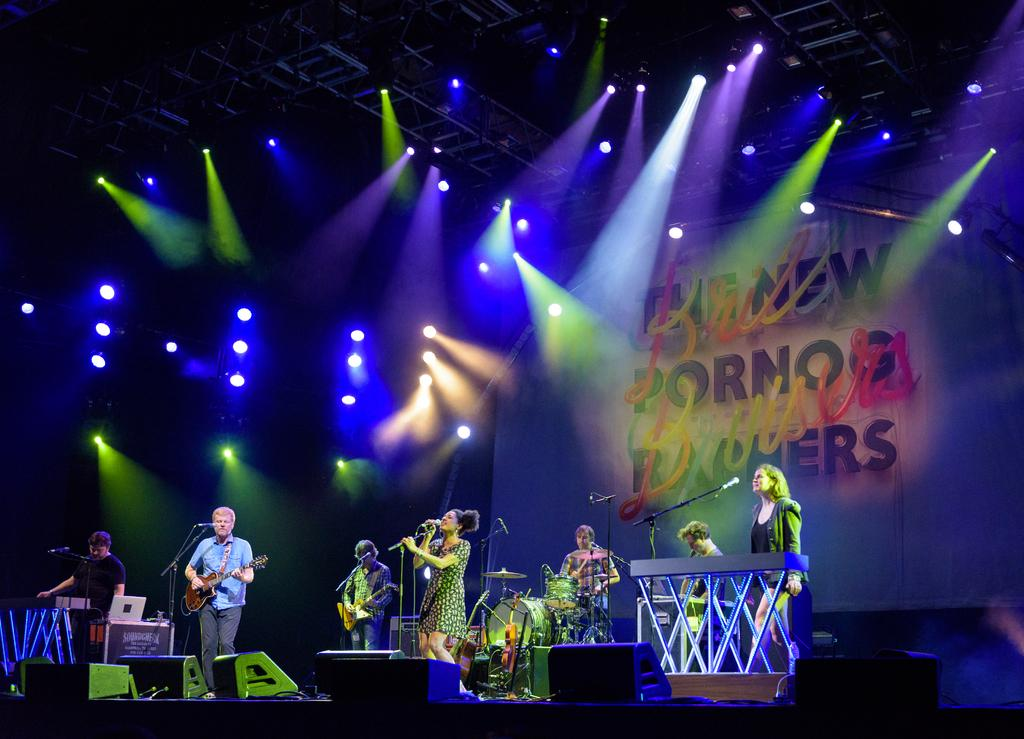What are the people in the image doing? The people in the image are playing music instruments and singing on microphones. Where are the people performing? They are on a stage. What can be seen above the stage in the image? There are lights above on the ceiling. What type of yoke is being used by the people on the stage? There is no yoke present in the image; the people are using microphones for singing. What feeling is being expressed by the people on the stage? The image does not convey the emotions or feelings of the people on the stage, so it cannot be determined from the image. 